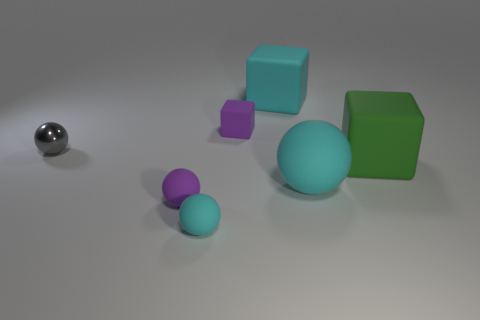Subtract all small blocks. How many blocks are left? 2 Subtract all gray spheres. How many spheres are left? 3 Add 2 green cylinders. How many objects exist? 9 Subtract all blue cubes. Subtract all brown balls. How many cubes are left? 3 Subtract all yellow cylinders. How many green blocks are left? 1 Subtract all big green shiny objects. Subtract all big rubber blocks. How many objects are left? 5 Add 2 large cyan matte balls. How many large cyan matte balls are left? 3 Add 5 small cyan spheres. How many small cyan spheres exist? 6 Subtract 0 yellow cylinders. How many objects are left? 7 Subtract all spheres. How many objects are left? 3 